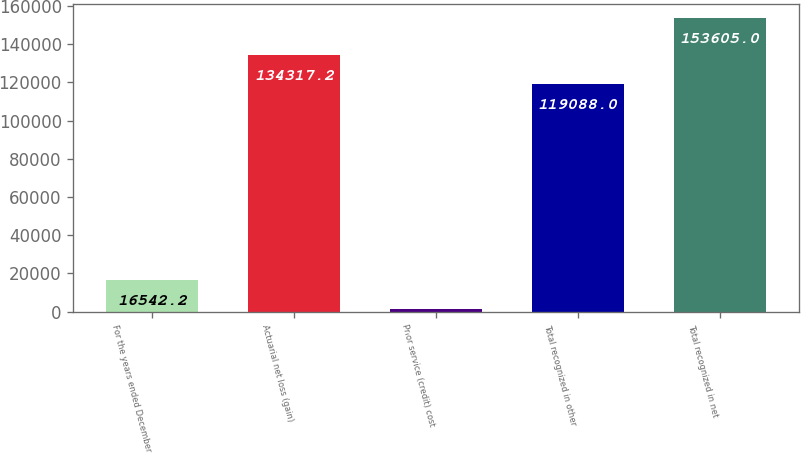Convert chart. <chart><loc_0><loc_0><loc_500><loc_500><bar_chart><fcel>For the years ended December<fcel>Actuarial net loss (gain)<fcel>Prior service (credit) cost<fcel>Total recognized in other<fcel>Total recognized in net<nl><fcel>16542.2<fcel>134317<fcel>1313<fcel>119088<fcel>153605<nl></chart> 